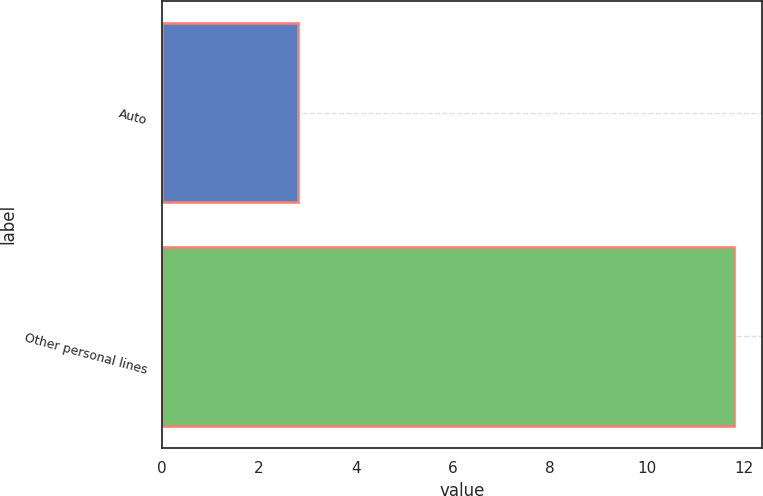Convert chart to OTSL. <chart><loc_0><loc_0><loc_500><loc_500><bar_chart><fcel>Auto<fcel>Other personal lines<nl><fcel>2.8<fcel>11.8<nl></chart> 